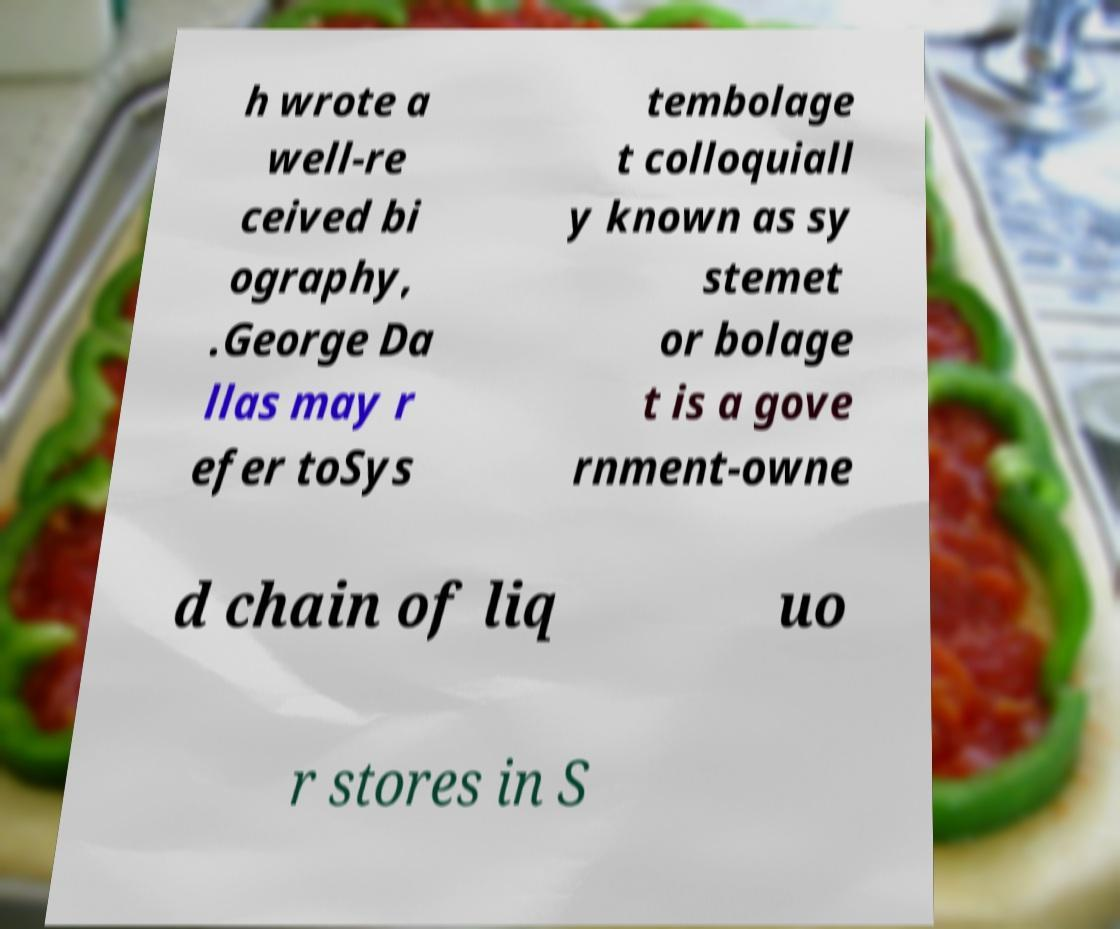Could you extract and type out the text from this image? h wrote a well-re ceived bi ography, .George Da llas may r efer toSys tembolage t colloquiall y known as sy stemet or bolage t is a gove rnment-owne d chain of liq uo r stores in S 